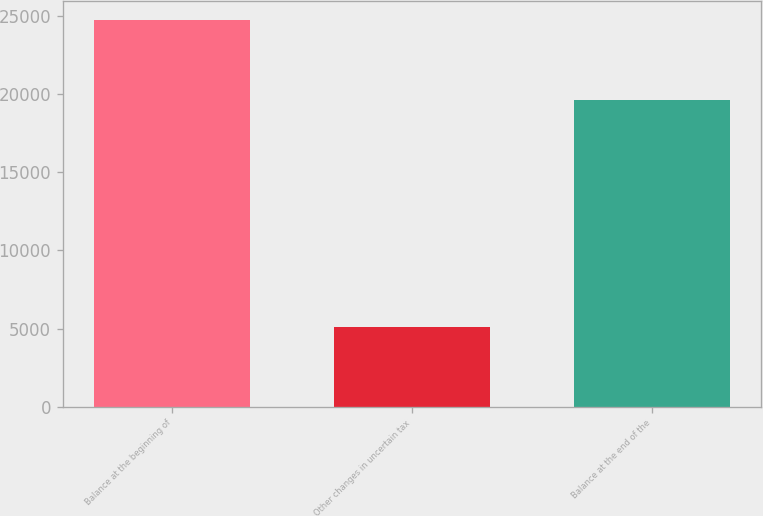Convert chart. <chart><loc_0><loc_0><loc_500><loc_500><bar_chart><fcel>Balance at the beginning of<fcel>Other changes in uncertain tax<fcel>Balance at the end of the<nl><fcel>24716<fcel>5120<fcel>19596<nl></chart> 